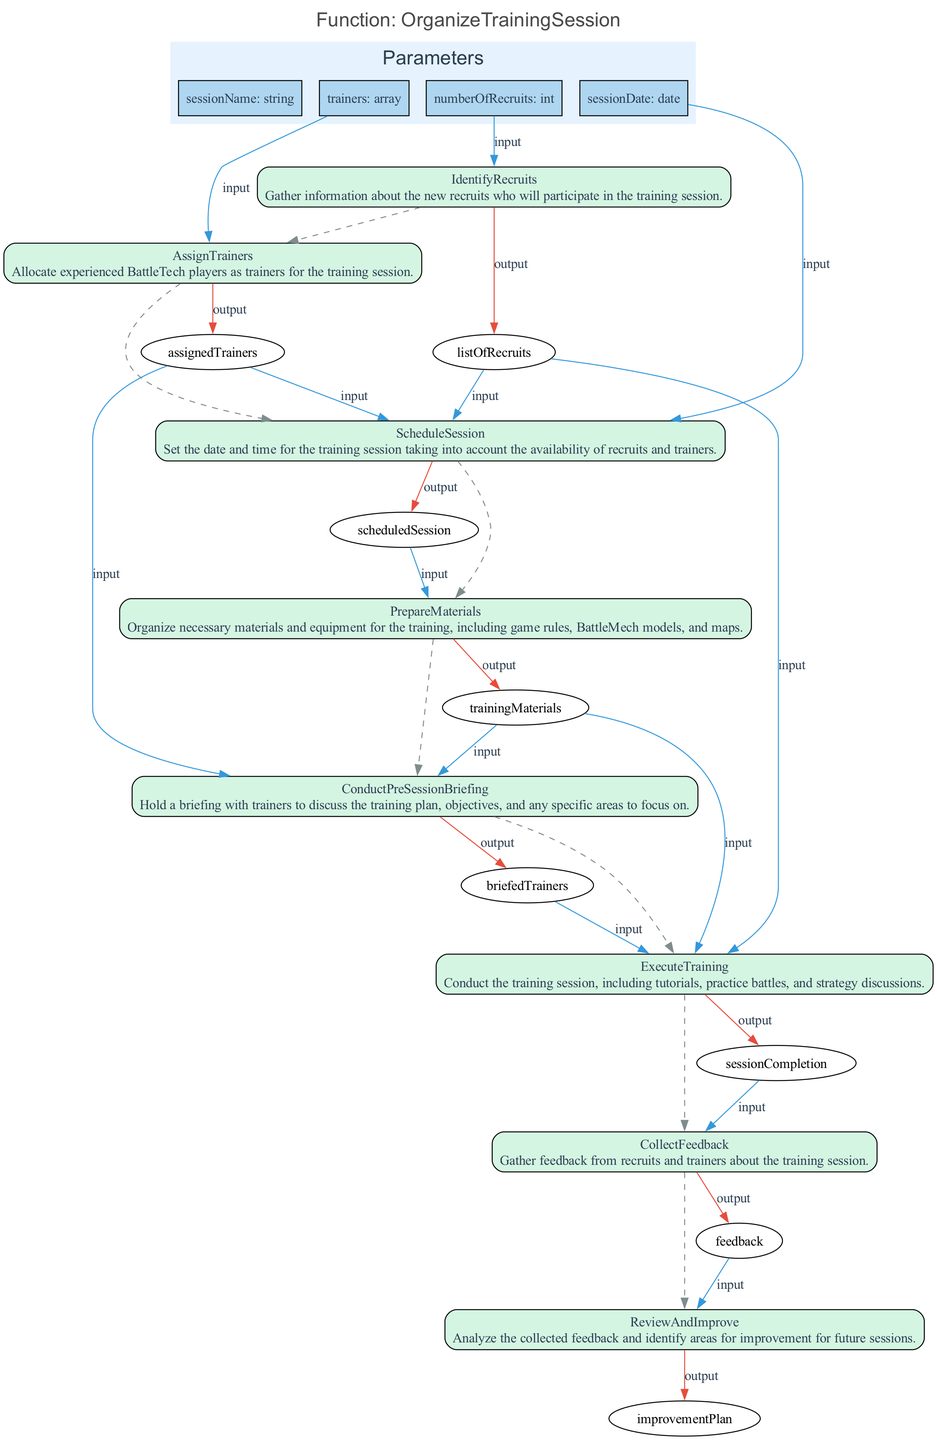What is the first action in the flowchart? The flowchart begins with the action "IdentifyRecruits," which is designated as the first step in organizing the training session.
Answer: IdentifyRecruits How many steps are there in total? The flowchart includes a total of 8 steps, each representing a distinct action taken to organize the training session.
Answer: 8 What is the input for the "PrepareMaterials" action? The "PrepareMaterials" action requires the output of the "ScheduleSession" step as its input, indicating that the scheduled session is necessary to determine what materials need to be prepared.
Answer: scheduledSession Who is involved in the "ConductPreSessionBriefing"? The "ConductPreSessionBriefing" step involves "assignedTrainers” and “trainingMaterials,” indicating that trainers must be briefed using the materials prepared for the session.
Answer: assignedTrainers, trainingMaterials What follows after "ExecuteTraining"? After "ExecuteTraining," the next step is "CollectFeedback," which shows that gathering feedback from recruits and trainers is the immediate action following the execution of the training session.
Answer: CollectFeedback What does the "ReviewAndImprove" action utilize as input? The "ReviewAndImprove" action uses "feedback" collected during the previous step as its input to analyze and identify potential areas for improvement.
Answer: feedback Which step has "sessionCompletion" as its input? The "CollectFeedback" step uses "sessionCompletion" as its input, meaning that feedback can only be gathered after the training session has been conducted.
Answer: sessionCompletion What is the last action in the diagram? The last action in the flowchart is "ReviewAndImprove," indicating that after gathering feedback, the final step is to analyze it for enhancing future sessions.
Answer: ReviewAndImprove 